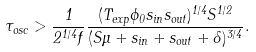<formula> <loc_0><loc_0><loc_500><loc_500>\tau _ { o s c } > \frac { 1 } { 2 ^ { 1 / 4 } f } \frac { ( T _ { e x p } \phi _ { 0 } s _ { i n } s _ { o u t } ) ^ { 1 / 4 } S ^ { 1 / 2 } } { ( S \mu + s _ { i n } + s _ { o u t } + \delta ) ^ { 3 / 4 } } .</formula> 